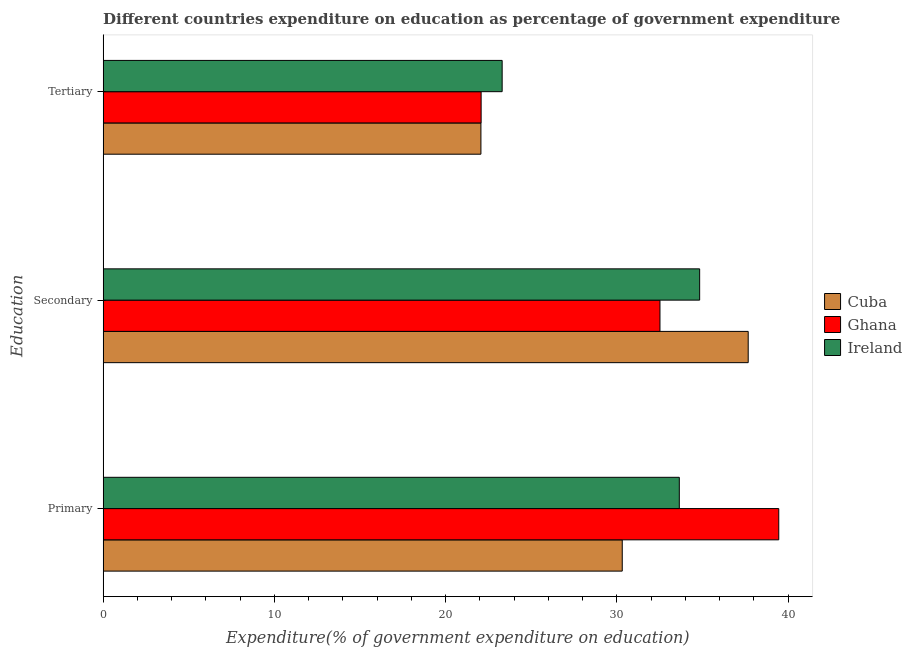Are the number of bars per tick equal to the number of legend labels?
Your answer should be compact. Yes. How many bars are there on the 3rd tick from the bottom?
Offer a very short reply. 3. What is the label of the 1st group of bars from the top?
Your answer should be compact. Tertiary. What is the expenditure on secondary education in Cuba?
Make the answer very short. 37.67. Across all countries, what is the maximum expenditure on secondary education?
Offer a very short reply. 37.67. Across all countries, what is the minimum expenditure on secondary education?
Your response must be concise. 32.52. In which country was the expenditure on secondary education maximum?
Your response must be concise. Cuba. What is the total expenditure on secondary education in the graph?
Ensure brevity in your answer.  105.02. What is the difference between the expenditure on primary education in Cuba and that in Ghana?
Make the answer very short. -9.14. What is the difference between the expenditure on tertiary education in Ghana and the expenditure on secondary education in Ireland?
Ensure brevity in your answer.  -12.76. What is the average expenditure on secondary education per country?
Provide a succinct answer. 35.01. What is the difference between the expenditure on primary education and expenditure on tertiary education in Ireland?
Provide a succinct answer. 10.35. What is the ratio of the expenditure on tertiary education in Ghana to that in Ireland?
Ensure brevity in your answer.  0.95. Is the difference between the expenditure on tertiary education in Ireland and Cuba greater than the difference between the expenditure on primary education in Ireland and Cuba?
Your response must be concise. No. What is the difference between the highest and the second highest expenditure on secondary education?
Offer a terse response. 2.84. What is the difference between the highest and the lowest expenditure on tertiary education?
Give a very brief answer. 1.24. In how many countries, is the expenditure on tertiary education greater than the average expenditure on tertiary education taken over all countries?
Provide a succinct answer. 1. What does the 2nd bar from the top in Tertiary represents?
Your response must be concise. Ghana. What does the 1st bar from the bottom in Tertiary represents?
Give a very brief answer. Cuba. Is it the case that in every country, the sum of the expenditure on primary education and expenditure on secondary education is greater than the expenditure on tertiary education?
Ensure brevity in your answer.  Yes. Are all the bars in the graph horizontal?
Your response must be concise. Yes. Are the values on the major ticks of X-axis written in scientific E-notation?
Your response must be concise. No. Does the graph contain any zero values?
Provide a short and direct response. No. Does the graph contain grids?
Your answer should be compact. No. How many legend labels are there?
Offer a terse response. 3. What is the title of the graph?
Your answer should be compact. Different countries expenditure on education as percentage of government expenditure. Does "Guam" appear as one of the legend labels in the graph?
Give a very brief answer. No. What is the label or title of the X-axis?
Keep it short and to the point. Expenditure(% of government expenditure on education). What is the label or title of the Y-axis?
Keep it short and to the point. Education. What is the Expenditure(% of government expenditure on education) of Cuba in Primary?
Provide a short and direct response. 30.31. What is the Expenditure(% of government expenditure on education) of Ghana in Primary?
Provide a succinct answer. 39.45. What is the Expenditure(% of government expenditure on education) of Ireland in Primary?
Ensure brevity in your answer.  33.65. What is the Expenditure(% of government expenditure on education) of Cuba in Secondary?
Make the answer very short. 37.67. What is the Expenditure(% of government expenditure on education) of Ghana in Secondary?
Keep it short and to the point. 32.52. What is the Expenditure(% of government expenditure on education) in Ireland in Secondary?
Your answer should be very brief. 34.83. What is the Expenditure(% of government expenditure on education) in Cuba in Tertiary?
Make the answer very short. 22.06. What is the Expenditure(% of government expenditure on education) in Ghana in Tertiary?
Offer a very short reply. 22.07. What is the Expenditure(% of government expenditure on education) of Ireland in Tertiary?
Make the answer very short. 23.3. Across all Education, what is the maximum Expenditure(% of government expenditure on education) of Cuba?
Provide a succinct answer. 37.67. Across all Education, what is the maximum Expenditure(% of government expenditure on education) of Ghana?
Offer a very short reply. 39.45. Across all Education, what is the maximum Expenditure(% of government expenditure on education) in Ireland?
Provide a short and direct response. 34.83. Across all Education, what is the minimum Expenditure(% of government expenditure on education) of Cuba?
Your answer should be compact. 22.06. Across all Education, what is the minimum Expenditure(% of government expenditure on education) in Ghana?
Your answer should be very brief. 22.07. Across all Education, what is the minimum Expenditure(% of government expenditure on education) in Ireland?
Make the answer very short. 23.3. What is the total Expenditure(% of government expenditure on education) in Cuba in the graph?
Your response must be concise. 90.04. What is the total Expenditure(% of government expenditure on education) of Ghana in the graph?
Provide a short and direct response. 94.04. What is the total Expenditure(% of government expenditure on education) in Ireland in the graph?
Your answer should be compact. 91.78. What is the difference between the Expenditure(% of government expenditure on education) in Cuba in Primary and that in Secondary?
Ensure brevity in your answer.  -7.36. What is the difference between the Expenditure(% of government expenditure on education) in Ghana in Primary and that in Secondary?
Offer a very short reply. 6.94. What is the difference between the Expenditure(% of government expenditure on education) of Ireland in Primary and that in Secondary?
Your response must be concise. -1.19. What is the difference between the Expenditure(% of government expenditure on education) of Cuba in Primary and that in Tertiary?
Offer a very short reply. 8.25. What is the difference between the Expenditure(% of government expenditure on education) of Ghana in Primary and that in Tertiary?
Your response must be concise. 17.38. What is the difference between the Expenditure(% of government expenditure on education) in Ireland in Primary and that in Tertiary?
Provide a succinct answer. 10.35. What is the difference between the Expenditure(% of government expenditure on education) of Cuba in Secondary and that in Tertiary?
Your response must be concise. 15.61. What is the difference between the Expenditure(% of government expenditure on education) of Ghana in Secondary and that in Tertiary?
Your response must be concise. 10.44. What is the difference between the Expenditure(% of government expenditure on education) in Ireland in Secondary and that in Tertiary?
Offer a terse response. 11.53. What is the difference between the Expenditure(% of government expenditure on education) in Cuba in Primary and the Expenditure(% of government expenditure on education) in Ghana in Secondary?
Offer a terse response. -2.2. What is the difference between the Expenditure(% of government expenditure on education) in Cuba in Primary and the Expenditure(% of government expenditure on education) in Ireland in Secondary?
Your answer should be compact. -4.52. What is the difference between the Expenditure(% of government expenditure on education) of Ghana in Primary and the Expenditure(% of government expenditure on education) of Ireland in Secondary?
Provide a succinct answer. 4.62. What is the difference between the Expenditure(% of government expenditure on education) of Cuba in Primary and the Expenditure(% of government expenditure on education) of Ghana in Tertiary?
Keep it short and to the point. 8.24. What is the difference between the Expenditure(% of government expenditure on education) in Cuba in Primary and the Expenditure(% of government expenditure on education) in Ireland in Tertiary?
Your response must be concise. 7.01. What is the difference between the Expenditure(% of government expenditure on education) of Ghana in Primary and the Expenditure(% of government expenditure on education) of Ireland in Tertiary?
Keep it short and to the point. 16.15. What is the difference between the Expenditure(% of government expenditure on education) of Cuba in Secondary and the Expenditure(% of government expenditure on education) of Ghana in Tertiary?
Keep it short and to the point. 15.6. What is the difference between the Expenditure(% of government expenditure on education) in Cuba in Secondary and the Expenditure(% of government expenditure on education) in Ireland in Tertiary?
Provide a short and direct response. 14.37. What is the difference between the Expenditure(% of government expenditure on education) in Ghana in Secondary and the Expenditure(% of government expenditure on education) in Ireland in Tertiary?
Ensure brevity in your answer.  9.22. What is the average Expenditure(% of government expenditure on education) in Cuba per Education?
Give a very brief answer. 30.01. What is the average Expenditure(% of government expenditure on education) in Ghana per Education?
Give a very brief answer. 31.35. What is the average Expenditure(% of government expenditure on education) of Ireland per Education?
Your response must be concise. 30.59. What is the difference between the Expenditure(% of government expenditure on education) of Cuba and Expenditure(% of government expenditure on education) of Ghana in Primary?
Your response must be concise. -9.14. What is the difference between the Expenditure(% of government expenditure on education) in Cuba and Expenditure(% of government expenditure on education) in Ireland in Primary?
Offer a very short reply. -3.33. What is the difference between the Expenditure(% of government expenditure on education) of Ghana and Expenditure(% of government expenditure on education) of Ireland in Primary?
Offer a very short reply. 5.81. What is the difference between the Expenditure(% of government expenditure on education) in Cuba and Expenditure(% of government expenditure on education) in Ghana in Secondary?
Your answer should be compact. 5.15. What is the difference between the Expenditure(% of government expenditure on education) of Cuba and Expenditure(% of government expenditure on education) of Ireland in Secondary?
Provide a succinct answer. 2.84. What is the difference between the Expenditure(% of government expenditure on education) of Ghana and Expenditure(% of government expenditure on education) of Ireland in Secondary?
Ensure brevity in your answer.  -2.32. What is the difference between the Expenditure(% of government expenditure on education) of Cuba and Expenditure(% of government expenditure on education) of Ghana in Tertiary?
Keep it short and to the point. -0.01. What is the difference between the Expenditure(% of government expenditure on education) of Cuba and Expenditure(% of government expenditure on education) of Ireland in Tertiary?
Provide a short and direct response. -1.24. What is the difference between the Expenditure(% of government expenditure on education) in Ghana and Expenditure(% of government expenditure on education) in Ireland in Tertiary?
Provide a succinct answer. -1.23. What is the ratio of the Expenditure(% of government expenditure on education) in Cuba in Primary to that in Secondary?
Make the answer very short. 0.8. What is the ratio of the Expenditure(% of government expenditure on education) of Ghana in Primary to that in Secondary?
Your response must be concise. 1.21. What is the ratio of the Expenditure(% of government expenditure on education) in Ireland in Primary to that in Secondary?
Your answer should be very brief. 0.97. What is the ratio of the Expenditure(% of government expenditure on education) of Cuba in Primary to that in Tertiary?
Keep it short and to the point. 1.37. What is the ratio of the Expenditure(% of government expenditure on education) in Ghana in Primary to that in Tertiary?
Provide a succinct answer. 1.79. What is the ratio of the Expenditure(% of government expenditure on education) of Ireland in Primary to that in Tertiary?
Offer a terse response. 1.44. What is the ratio of the Expenditure(% of government expenditure on education) in Cuba in Secondary to that in Tertiary?
Offer a very short reply. 1.71. What is the ratio of the Expenditure(% of government expenditure on education) of Ghana in Secondary to that in Tertiary?
Your response must be concise. 1.47. What is the ratio of the Expenditure(% of government expenditure on education) in Ireland in Secondary to that in Tertiary?
Offer a terse response. 1.49. What is the difference between the highest and the second highest Expenditure(% of government expenditure on education) in Cuba?
Offer a very short reply. 7.36. What is the difference between the highest and the second highest Expenditure(% of government expenditure on education) in Ghana?
Your response must be concise. 6.94. What is the difference between the highest and the second highest Expenditure(% of government expenditure on education) in Ireland?
Offer a terse response. 1.19. What is the difference between the highest and the lowest Expenditure(% of government expenditure on education) of Cuba?
Offer a very short reply. 15.61. What is the difference between the highest and the lowest Expenditure(% of government expenditure on education) of Ghana?
Make the answer very short. 17.38. What is the difference between the highest and the lowest Expenditure(% of government expenditure on education) in Ireland?
Offer a terse response. 11.53. 